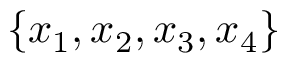Convert formula to latex. <formula><loc_0><loc_0><loc_500><loc_500>\{ x _ { 1 } , x _ { 2 } , x _ { 3 } , x _ { 4 } \}</formula> 